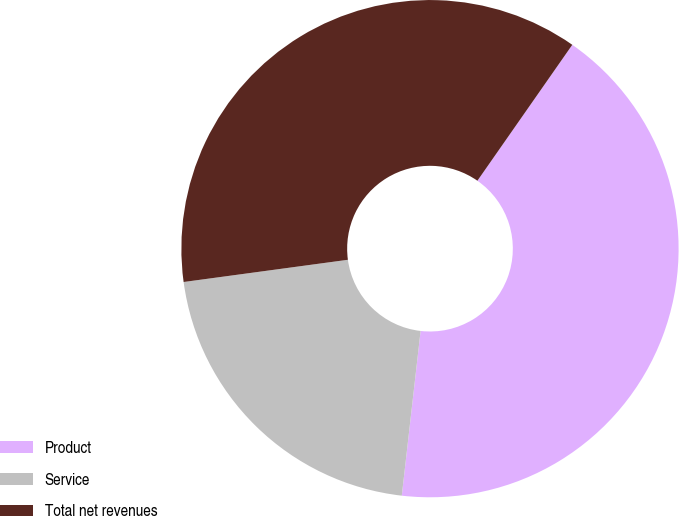Convert chart. <chart><loc_0><loc_0><loc_500><loc_500><pie_chart><fcel>Product<fcel>Service<fcel>Total net revenues<nl><fcel>42.11%<fcel>21.05%<fcel>36.84%<nl></chart> 